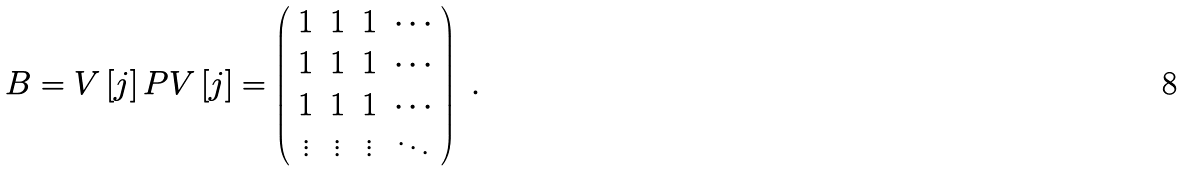Convert formula to latex. <formula><loc_0><loc_0><loc_500><loc_500>B = V \left [ j \right ] P V \left [ j \right ] = \left ( \begin{array} [ c ] { c c c c } 1 & 1 & 1 & \cdots \\ 1 & 1 & 1 & \cdots \\ 1 & 1 & 1 & \cdots \\ \vdots & \vdots & \vdots & \ddots \end{array} \right ) \ .</formula> 